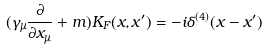Convert formula to latex. <formula><loc_0><loc_0><loc_500><loc_500>( \gamma _ { \mu } \frac { \partial } { \partial x _ { \mu } } + m ) K _ { F } ( x , x ^ { \prime } ) = - i \delta ^ { ( 4 ) } ( x - x ^ { \prime } )</formula> 